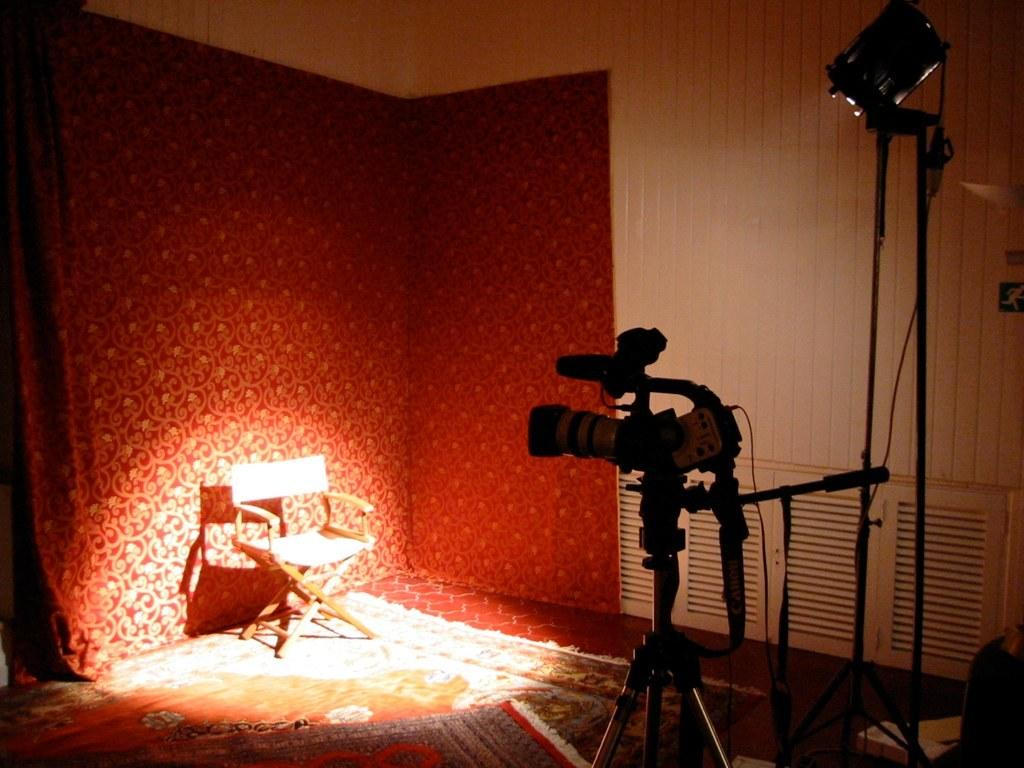What type of furniture is in the image? There is a chair in the image. What device is used for capturing images in the image? There is a camera in the image. What can be seen illuminating the scene in the image? There is light in the image. What type of flooring is present in the image? There is a carpet in the image. What color is the background of the image? The background of the image is red. What type of material is used for the wall in the image? There is a wooden wall in the image. What type of judge is present in the image? There is no judge present in the image. What kind of offer is being made in the image? There is no offer being made in the image. 